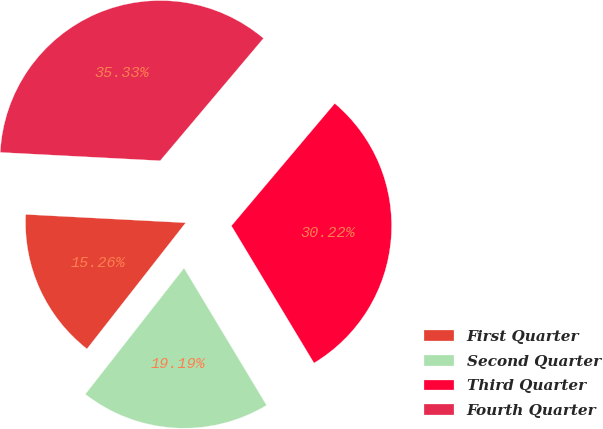Convert chart. <chart><loc_0><loc_0><loc_500><loc_500><pie_chart><fcel>First Quarter<fcel>Second Quarter<fcel>Third Quarter<fcel>Fourth Quarter<nl><fcel>15.26%<fcel>19.19%<fcel>30.22%<fcel>35.33%<nl></chart> 